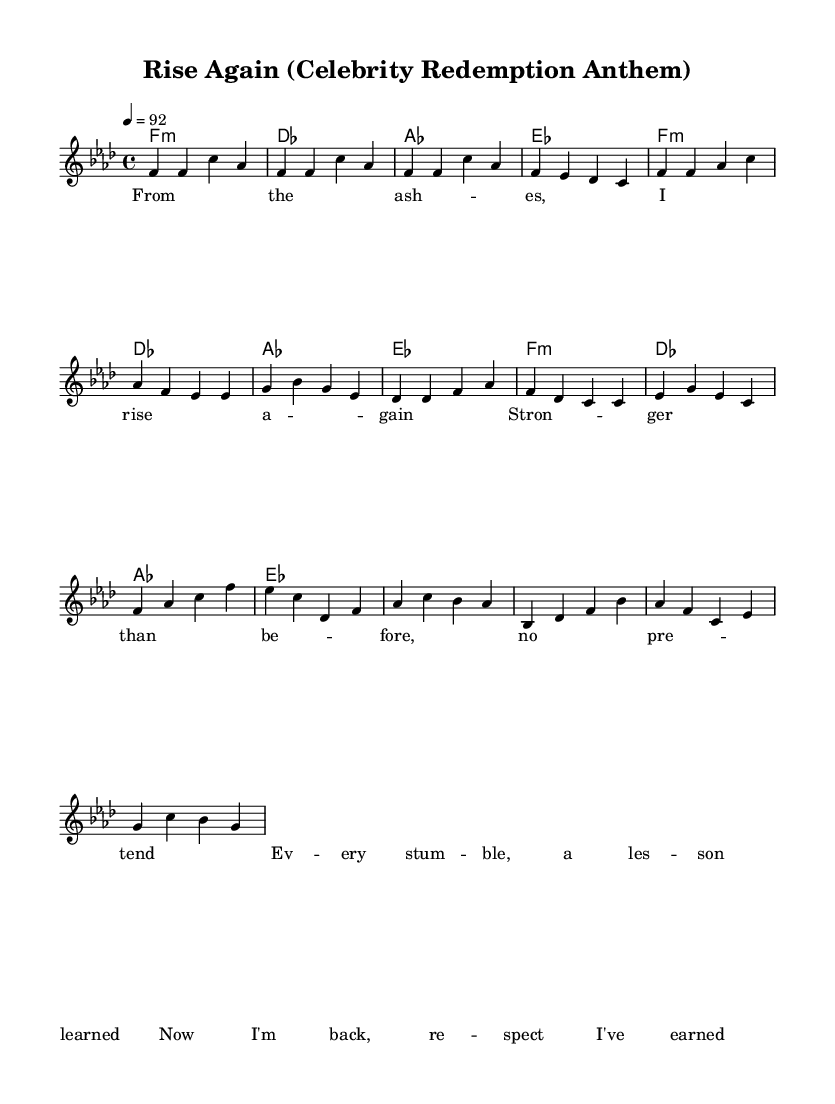What is the key signature of this music? The key signature is F minor, which has four flats in its signature. This can be identified by the key signature marking at the beginning of the staff.
Answer: F minor What is the time signature of this music? The time signature is 4/4, which indicates there are four beats in each measure and the quarter note gets one beat. This can be seen at the beginning of the score where the time signature is displayed after the key signature.
Answer: 4/4 What is the tempo marking for this piece? The tempo marking is 92 beats per minute, which specifies the speed of the music. This is indicated by the tempo marking in the global settings of the sheet music.
Answer: 92 How many measures are there in the chorus section? The chorus section consists of four measures, which can be counted by identifying the distinct lines in the sheet music that correspond to the chorus lyrics.
Answer: 4 What is the first lyric line of the verse? The first lyric line of the verse is "From the ash -- es, I rise a -- gain," found at the start of the verse section in the lyrics part of the score.
Answer: From the ash -- es, I rise a -- gain How many chords are listed in the harmonies? There are four different chords listed in the harmonies: F minor, D flat, A flat, and E flat. This can be deduced from the chord symbols written above the measures in the harmonies section.
Answer: 4 What mantra is conveyed through the lyrics of this anthem? The anthem conveys the mantra of resilience and redemption by emphasizing strength gained from past struggles, as showcased through the lyrics that focus on rising again and learning from stumbles.
Answer: Resilience 